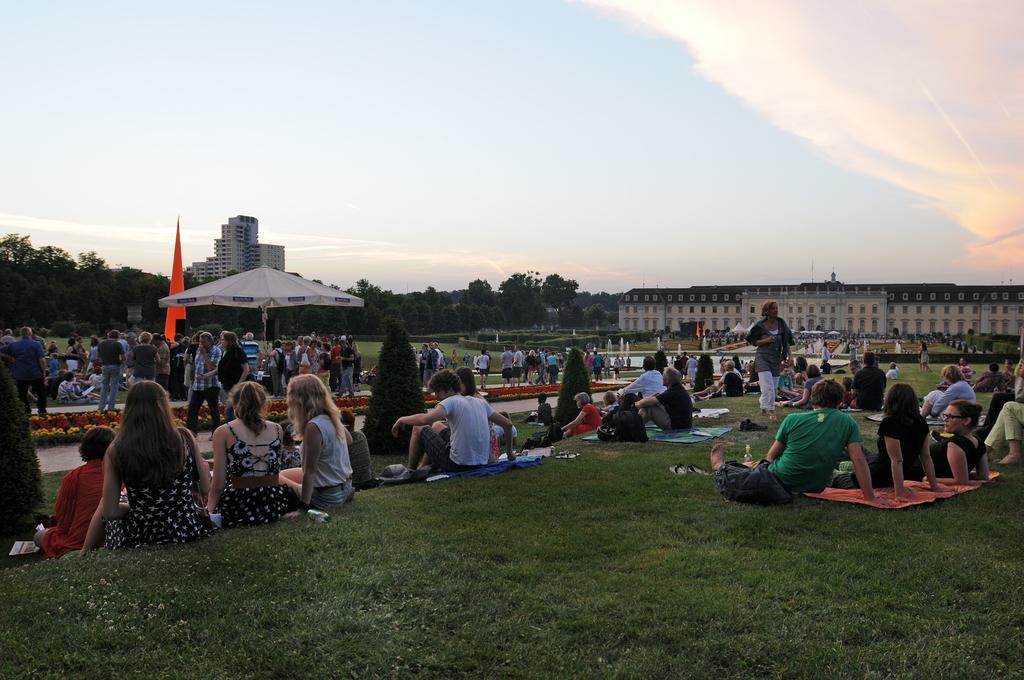How would you summarize this image in a sentence or two? In this image there are many people sitting on the ground. There is grass on the ground. In front of them there is a path. On the other side of the path there is a table umbrella on the ground. Around the table umbrella there are people standing. In the background there are trees and buildings. At the top there is the sky. 